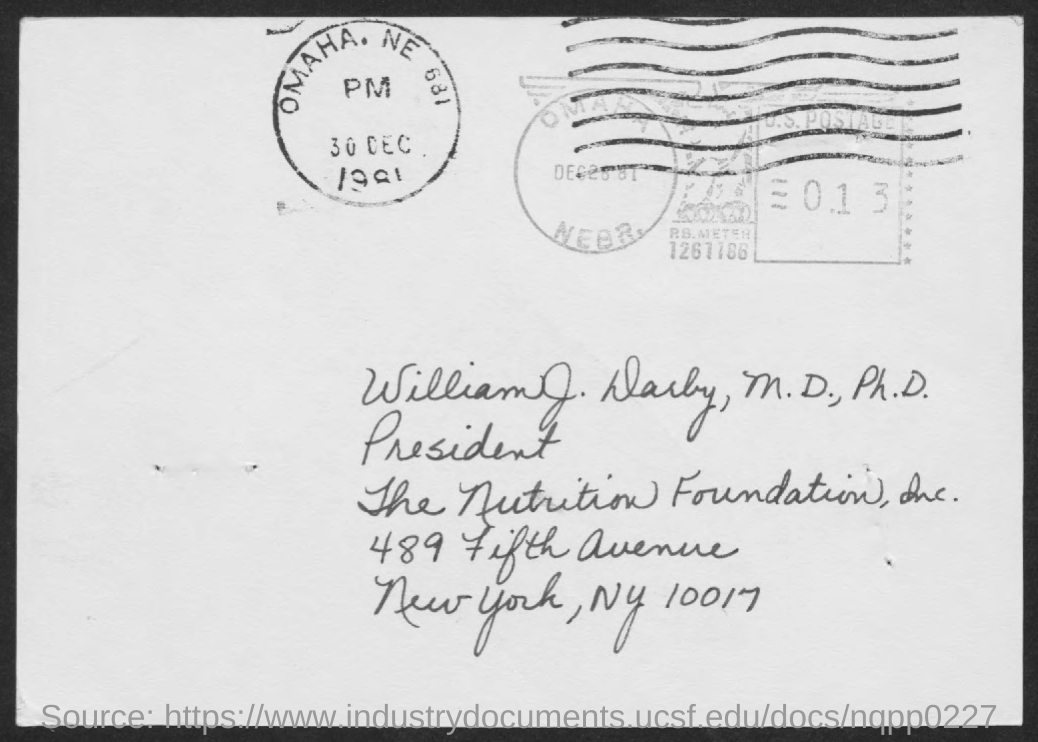What is the name on the letter?
Your response must be concise. William J. Darby. What is the designation of Dr. William J. Darby?
Your answer should be very brief. President. Which city is the nutrition foundation in?
Your answer should be compact. New york. 